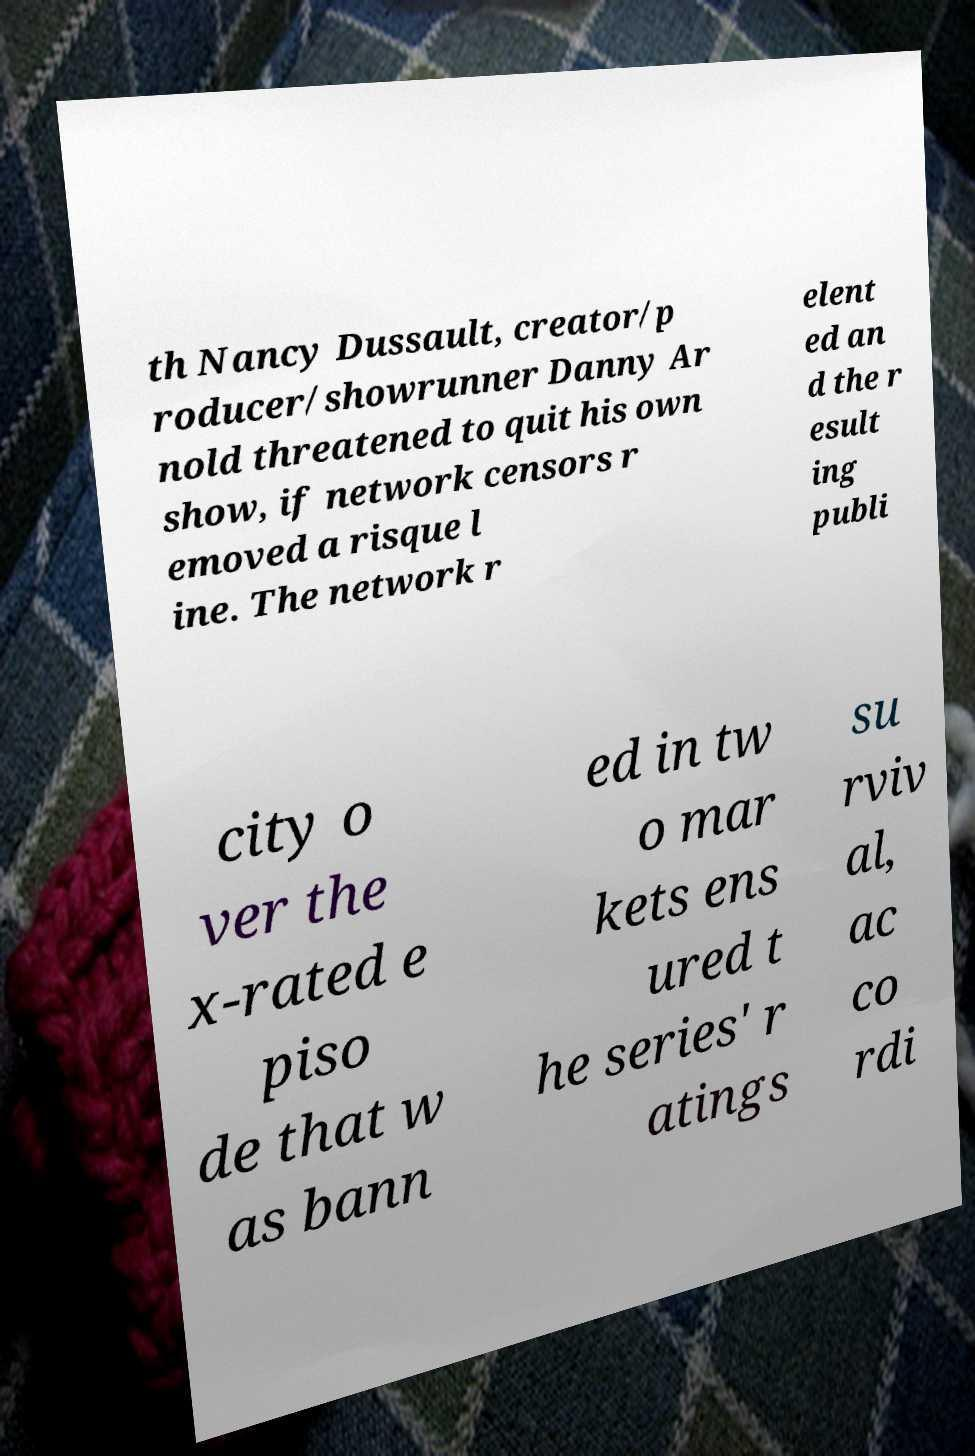Could you assist in decoding the text presented in this image and type it out clearly? th Nancy Dussault, creator/p roducer/showrunner Danny Ar nold threatened to quit his own show, if network censors r emoved a risque l ine. The network r elent ed an d the r esult ing publi city o ver the x-rated e piso de that w as bann ed in tw o mar kets ens ured t he series' r atings su rviv al, ac co rdi 